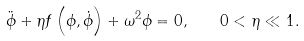Convert formula to latex. <formula><loc_0><loc_0><loc_500><loc_500>\ddot { \phi } + \eta f \left ( \phi , \dot { \phi } \right ) + \omega ^ { 2 } \phi = 0 , \quad 0 < \eta \ll 1 .</formula> 